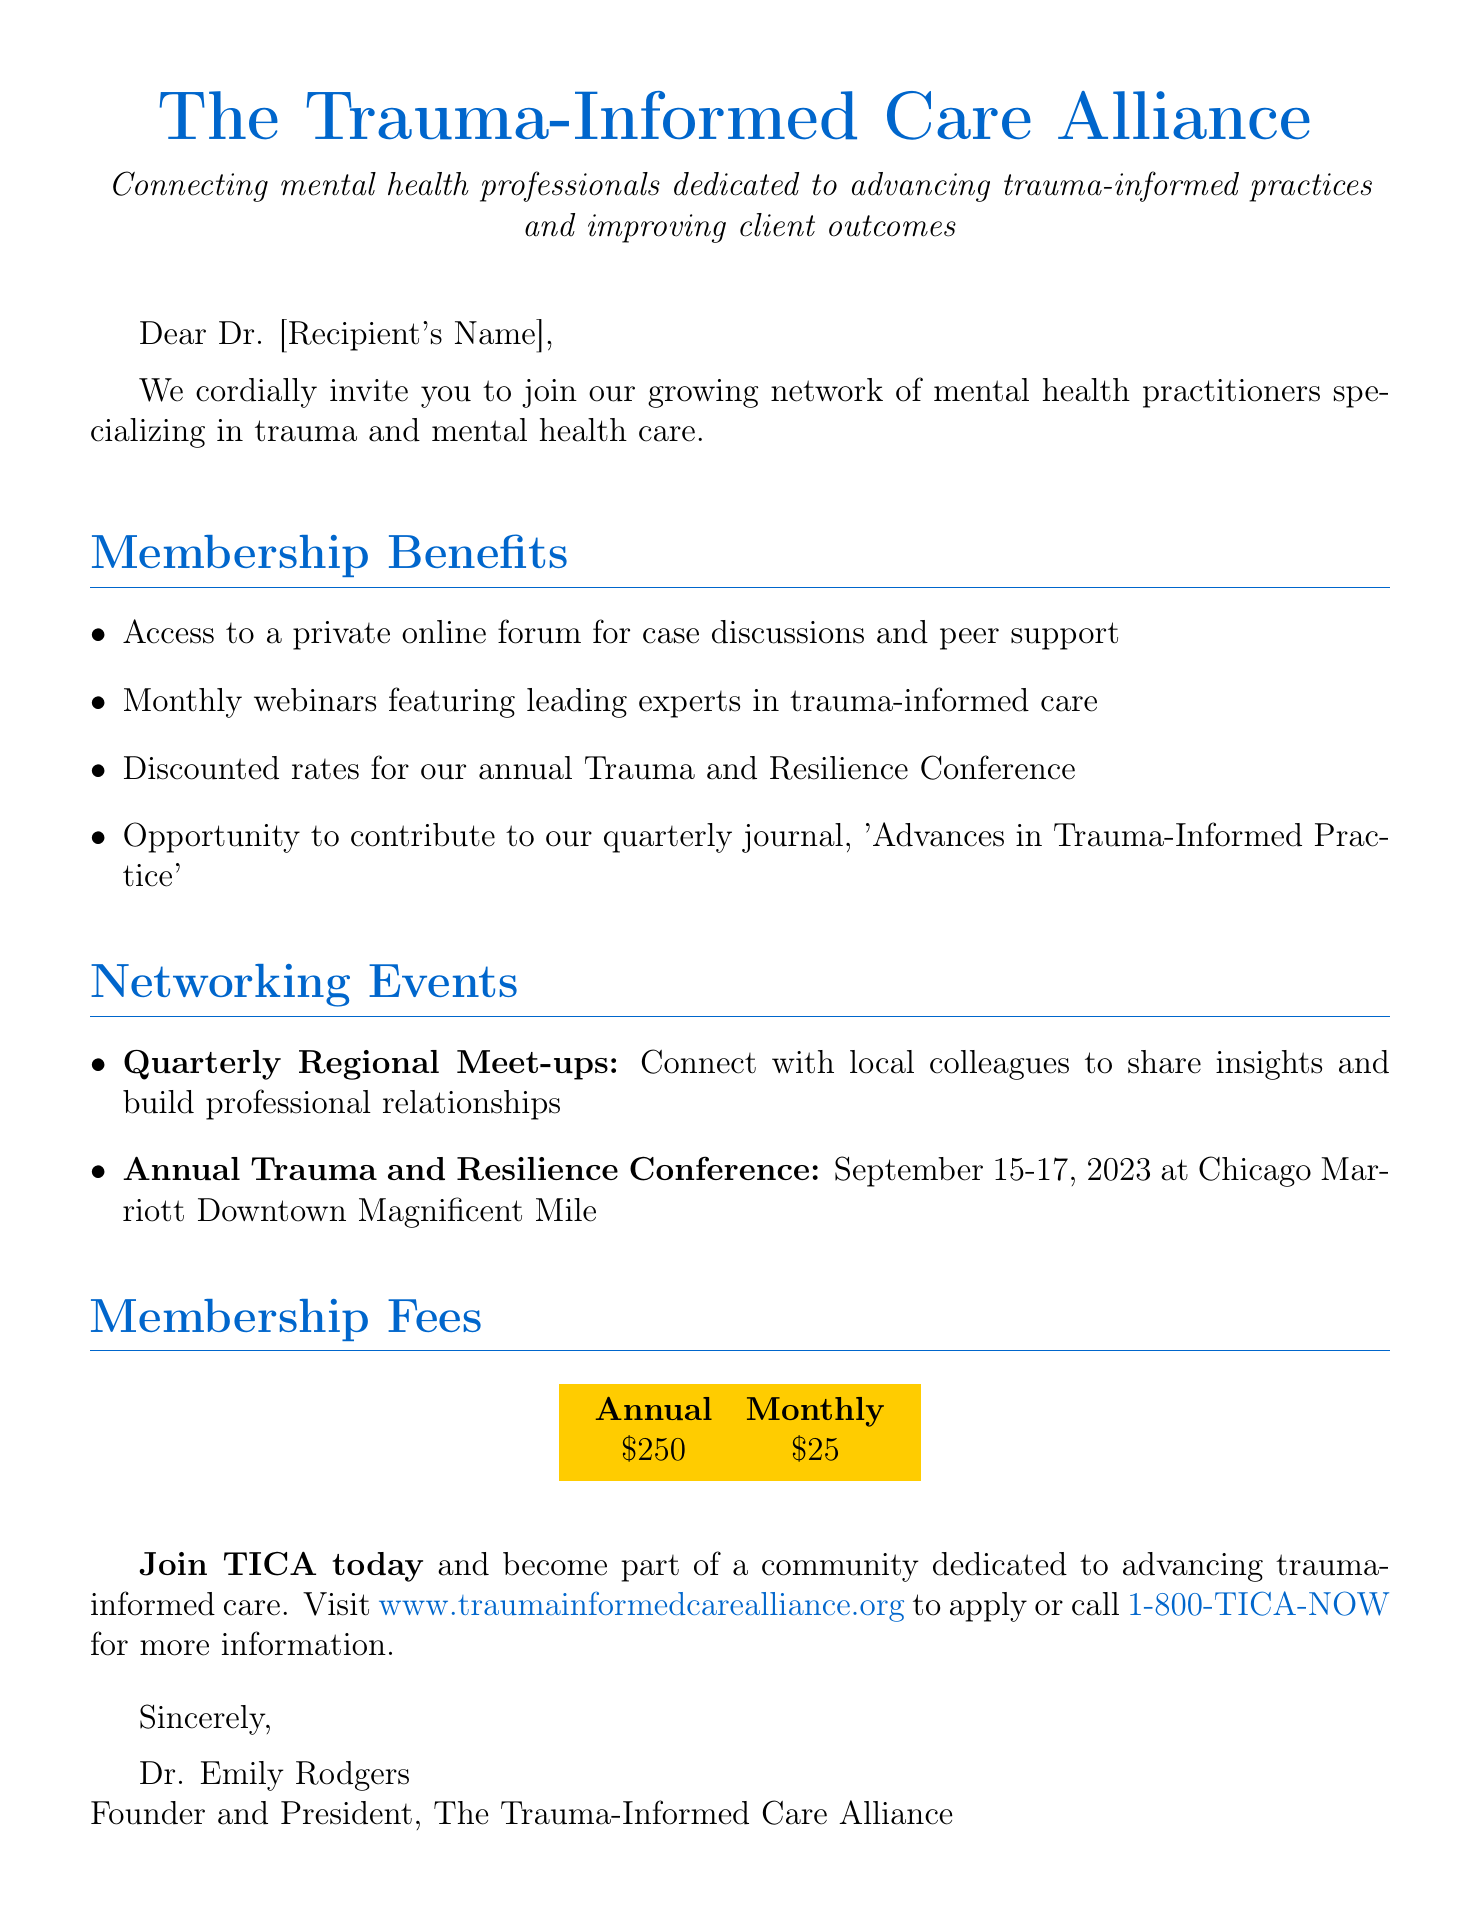What is the name of the network? The document states that the network is called "The Trauma-Informed Care Alliance (TICA)."
Answer: The Trauma-Informed Care Alliance (TICA) What are the membership fees for one year? The annual membership fee is mentioned directly in the document.
Answer: $250 What is the date of the Annual Trauma and Resilience Conference? The document specifies the dates of the conference as September 15-17, 2023.
Answer: September 15-17, 2023 Who is the founder of the network? The closing signature reveals that Dr. Emily Rodgers is the founder.
Answer: Dr. Emily Rodgers What is one benefit of membership? The document lists various benefits; one example is access to a private online forum.
Answer: Access to a private online forum for case discussions and peer support How often do the Quarterly Regional Meet-ups occur? The term "Quarterly" indicates that these meet-ups happen every three months.
Answer: Quarterly What is the main mission of TICA? The mission statement provided in the introduction summarizes the network's purpose.
Answer: Connecting mental health professionals dedicated to advancing trauma-informed practices and improving client outcomes What is the title of the quarterly journal? The document specifically mentions the title of the journal.
Answer: Advances in Trauma-Informed Practice 